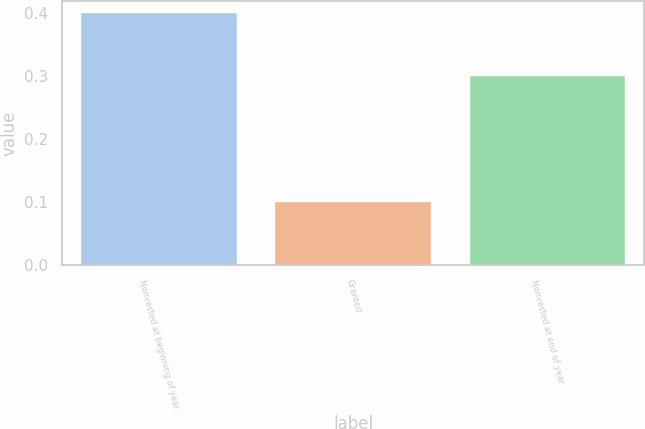<chart> <loc_0><loc_0><loc_500><loc_500><bar_chart><fcel>Nonvested at beginning of year<fcel>Granted<fcel>Nonvested at end of year<nl><fcel>0.4<fcel>0.1<fcel>0.3<nl></chart> 